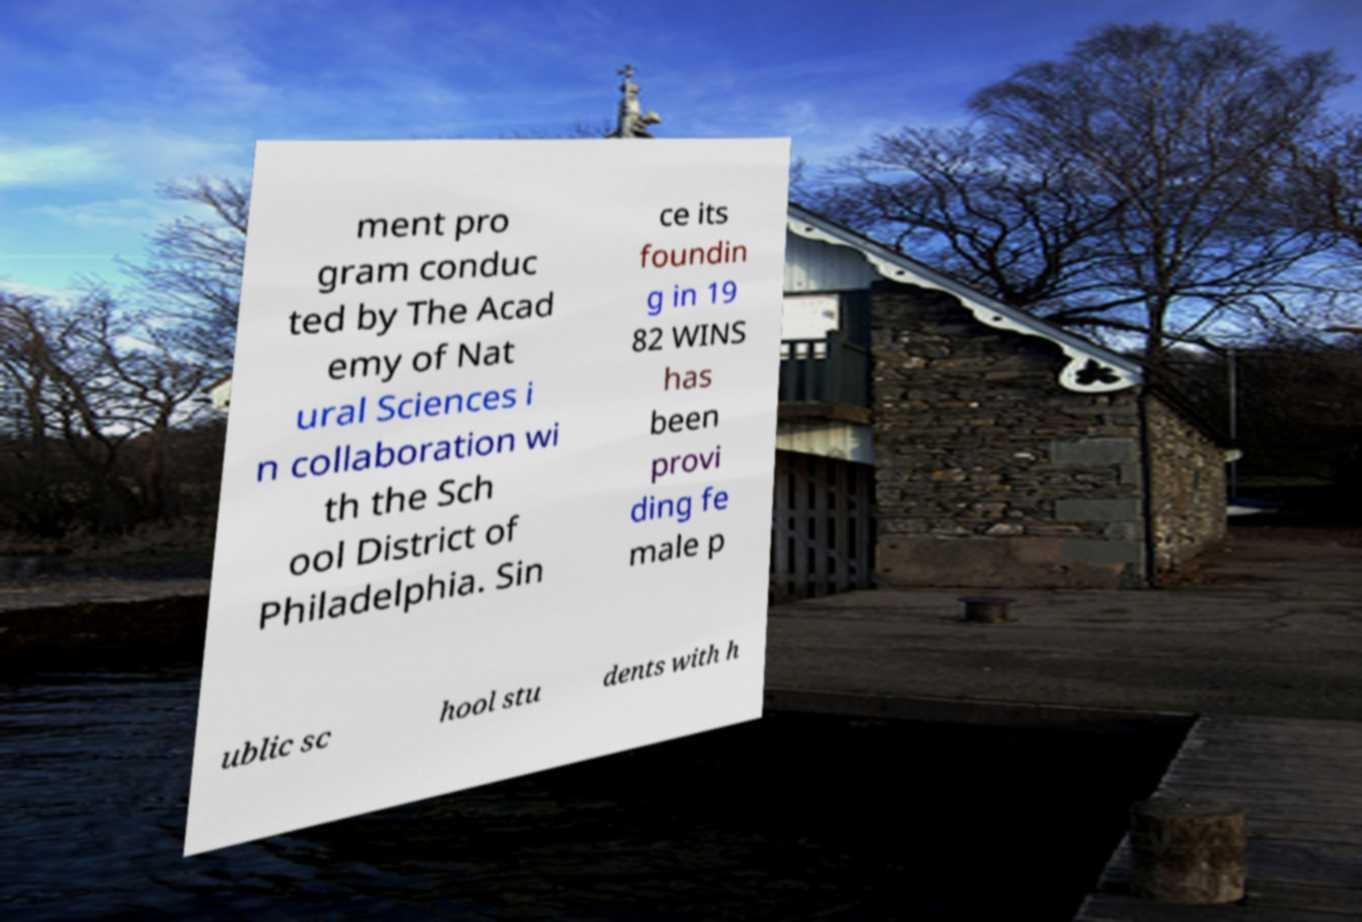What messages or text are displayed in this image? I need them in a readable, typed format. ment pro gram conduc ted by The Acad emy of Nat ural Sciences i n collaboration wi th the Sch ool District of Philadelphia. Sin ce its foundin g in 19 82 WINS has been provi ding fe male p ublic sc hool stu dents with h 